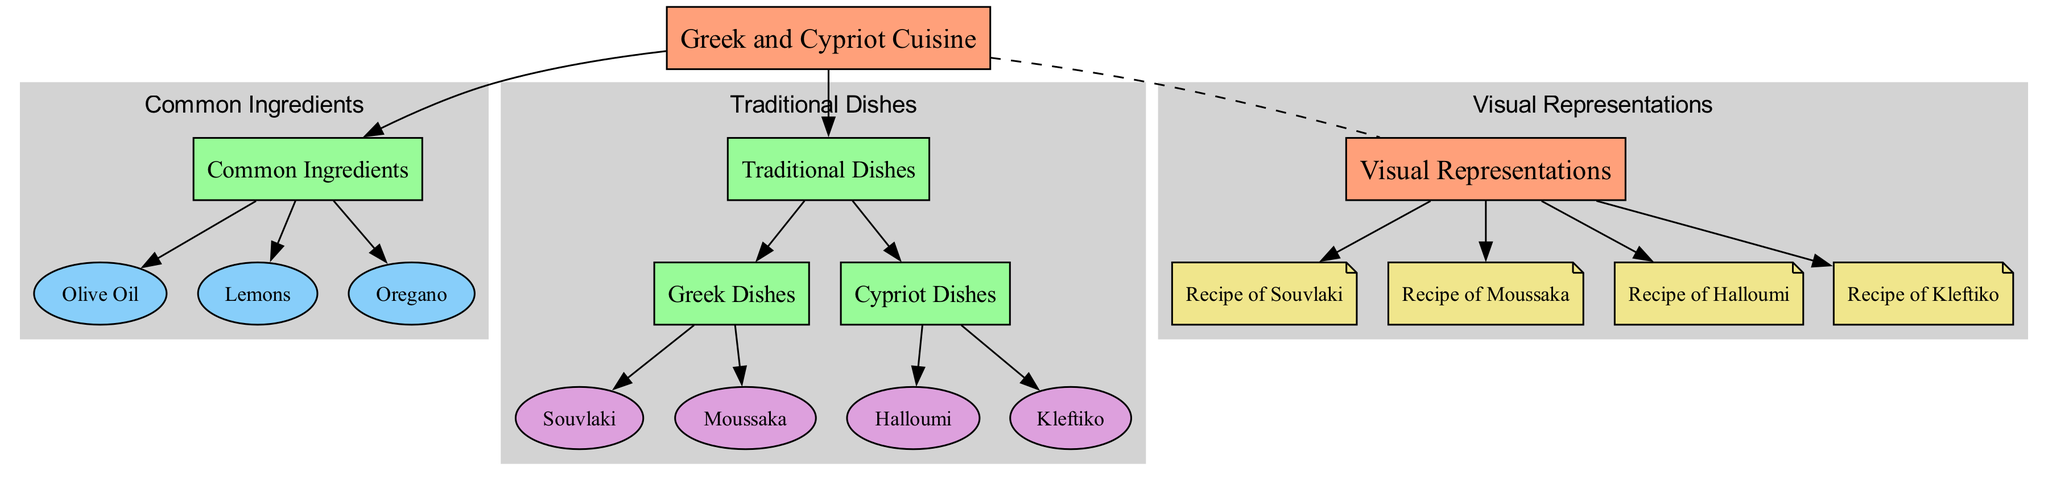What is the main category of the diagram? The main category at the top of the diagram is represented by the node labeled "Greek and Cypriot Cuisine," which signifies the overall focus area of the diagram.
Answer: Greek and Cypriot Cuisine How many common ingredients are listed? The diagram includes three common ingredients: Olive Oil, Lemons, and Oregano, which are all part of the "Common Ingredients" subcategory. Counting these nodes gives us three ingredients.
Answer: 3 What dish is associated with the Greek Dishes subcategory? The Greek Dishes subcategory lists Souvlaki and Moussaka. Therefore, both dishes are associated with this subcategory.
Answer: Souvlaki, Moussaka Which ingredient is a type of citrus fruit? Among the common ingredients listed, "Lemons" is the only ingredient that is specifically identified as a citrus fruit within the diagram.
Answer: Lemons What is the relationship between "Greek and Cypriot Cuisine" and "Visual Representations"? The relationship between these two categories is an association, indicating that there are visual representations (recipes) that relate directly to Greek and Cypriot cuisine, connecting them conceptually rather than hierarchically.
Answer: Association How many traditional dishes are there in total? By counting the nodes under "Traditional Dishes," which includes Greek Dishes (2) and Cypriot Dishes (2), the total comes to four traditional dishes overall: Souvlaki, Moussaka, Halloumi, and Kleftiko.
Answer: 4 What type of node represents the recipes in the diagram? The node type that represents the recipes in the diagram is labeled as "recipe_visual," which is designed to show visual representations of the cooking recipes associated with the dishes.
Answer: recipe_visual Which dish is specifically labeled as a Cypriot dish? Among the dishes listed under the "Cypriot Dishes" subcategory, "Halloumi" and "Kleftiko" are the dishes identified, leading to the recognition of either dish as a Cypriot dish.
Answer: Halloumi, Kleftiko 